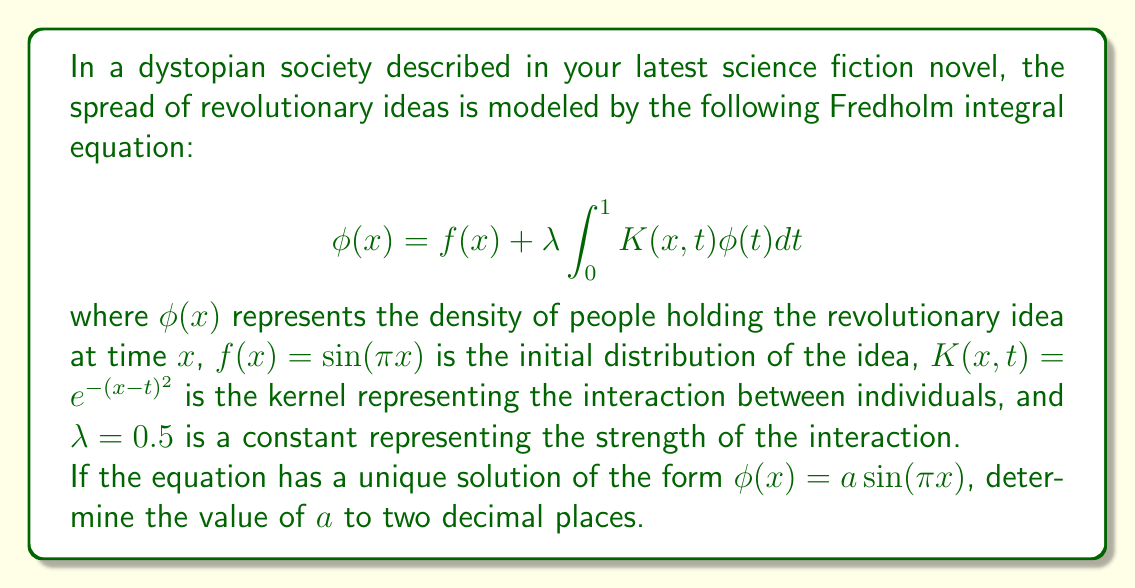What is the answer to this math problem? To solve this problem, we'll follow these steps:

1) First, we substitute the given form of the solution into the integral equation:

   $$a\sin(\pi x) = \sin(\pi x) + 0.5 \int_0^1 e^{-(x-t)^2} a\sin(\pi t)dt$$

2) We can simplify this by dividing both sides by $\sin(\pi x)$:

   $$a = 1 + \frac{0.5}{sin(\pi x)} \int_0^1 e^{-(x-t)^2} a\sin(\pi t)dt$$

3) For this equation to be true for all $x$, the right-hand side must be constant. We can evaluate it at any convenient point, such as $x = 0.5$:

   $$a = 1 + 0.5a \int_0^1 e^{-(0.5-t)^2} \sin(\pi t)dt$$

4) Let's denote the integral as $I$:

   $$I = \int_0^1 e^{-(0.5-t)^2} \sin(\pi t)dt$$

5) This integral doesn't have a simple closed form, so we need to evaluate it numerically. Using a computer algebra system or numerical integration method, we find:

   $$I \approx 0.4839$$

6) Now we can solve for $a$:

   $$a = 1 + 0.5a(0.4839)$$
   $$a = 1 + 0.24195a$$
   $$0.75805a = 1$$
   $$a = \frac{1}{0.75805} \approx 1.3191$$

7) Rounding to two decimal places, we get $a \approx 1.32$.
Answer: 1.32 